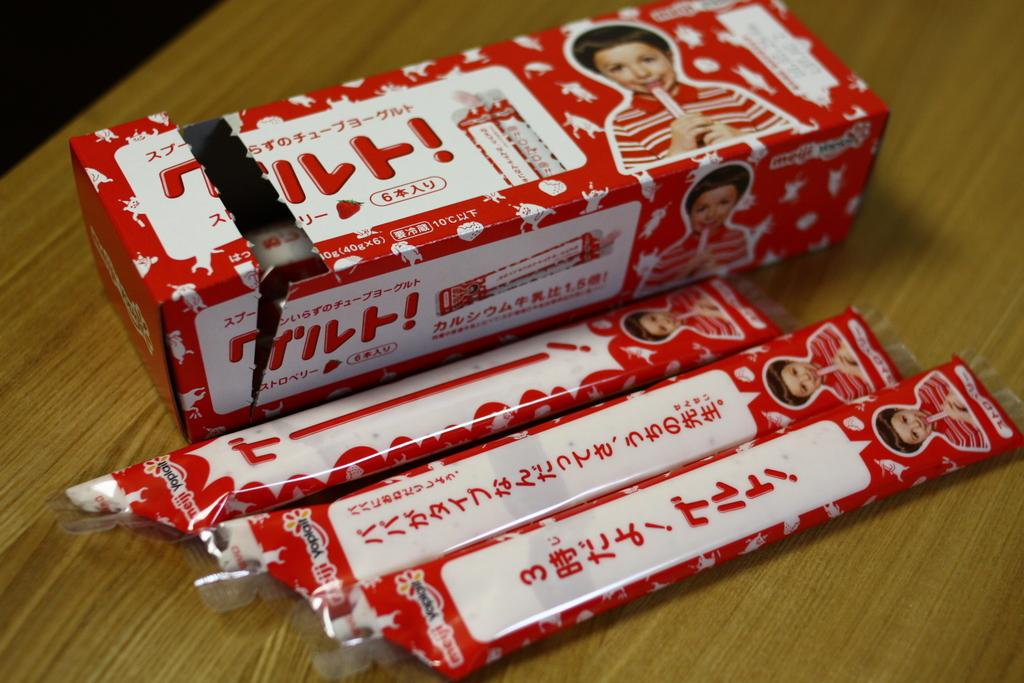What is the main subject of the image? The main subject of the image is candies. Where are the candies located in the image? The candies are in the center of the image. What else can be seen in the image related to the candies? There is a candy box on the table. What is the cause of the downtown traffic in the image? There is no downtown traffic or any reference to a downtown area in the image; it only features candies and a candy box. 